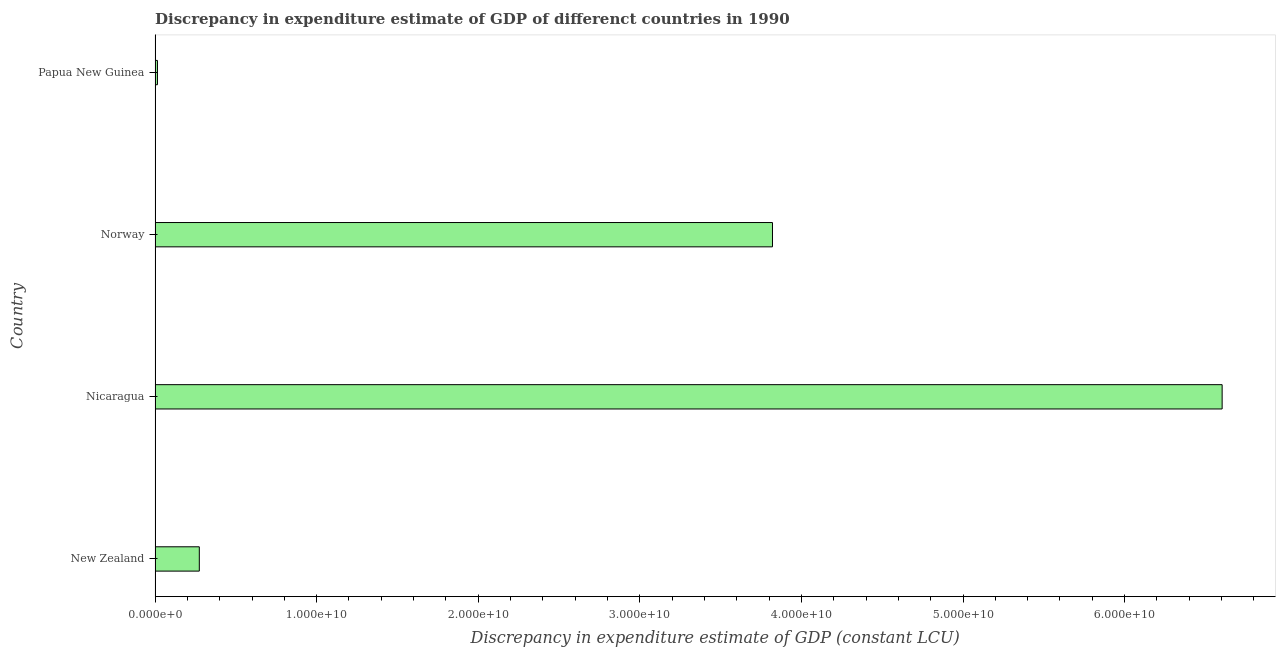Does the graph contain any zero values?
Make the answer very short. No. What is the title of the graph?
Offer a very short reply. Discrepancy in expenditure estimate of GDP of differenct countries in 1990. What is the label or title of the X-axis?
Provide a short and direct response. Discrepancy in expenditure estimate of GDP (constant LCU). What is the label or title of the Y-axis?
Ensure brevity in your answer.  Country. What is the discrepancy in expenditure estimate of gdp in Papua New Guinea?
Give a very brief answer. 1.49e+08. Across all countries, what is the maximum discrepancy in expenditure estimate of gdp?
Keep it short and to the point. 6.60e+1. Across all countries, what is the minimum discrepancy in expenditure estimate of gdp?
Provide a short and direct response. 1.49e+08. In which country was the discrepancy in expenditure estimate of gdp maximum?
Keep it short and to the point. Nicaragua. In which country was the discrepancy in expenditure estimate of gdp minimum?
Ensure brevity in your answer.  Papua New Guinea. What is the sum of the discrepancy in expenditure estimate of gdp?
Give a very brief answer. 1.07e+11. What is the difference between the discrepancy in expenditure estimate of gdp in Norway and Papua New Guinea?
Offer a very short reply. 3.81e+1. What is the average discrepancy in expenditure estimate of gdp per country?
Make the answer very short. 2.68e+1. What is the median discrepancy in expenditure estimate of gdp?
Keep it short and to the point. 2.05e+1. What is the ratio of the discrepancy in expenditure estimate of gdp in New Zealand to that in Norway?
Your answer should be compact. 0.07. What is the difference between the highest and the second highest discrepancy in expenditure estimate of gdp?
Offer a terse response. 2.78e+1. What is the difference between the highest and the lowest discrepancy in expenditure estimate of gdp?
Offer a very short reply. 6.59e+1. In how many countries, is the discrepancy in expenditure estimate of gdp greater than the average discrepancy in expenditure estimate of gdp taken over all countries?
Your answer should be very brief. 2. How many bars are there?
Your answer should be very brief. 4. How many countries are there in the graph?
Your answer should be very brief. 4. What is the Discrepancy in expenditure estimate of GDP (constant LCU) of New Zealand?
Your answer should be very brief. 2.74e+09. What is the Discrepancy in expenditure estimate of GDP (constant LCU) in Nicaragua?
Your answer should be compact. 6.60e+1. What is the Discrepancy in expenditure estimate of GDP (constant LCU) of Norway?
Offer a terse response. 3.82e+1. What is the Discrepancy in expenditure estimate of GDP (constant LCU) of Papua New Guinea?
Your answer should be compact. 1.49e+08. What is the difference between the Discrepancy in expenditure estimate of GDP (constant LCU) in New Zealand and Nicaragua?
Offer a very short reply. -6.33e+1. What is the difference between the Discrepancy in expenditure estimate of GDP (constant LCU) in New Zealand and Norway?
Your response must be concise. -3.55e+1. What is the difference between the Discrepancy in expenditure estimate of GDP (constant LCU) in New Zealand and Papua New Guinea?
Provide a short and direct response. 2.59e+09. What is the difference between the Discrepancy in expenditure estimate of GDP (constant LCU) in Nicaragua and Norway?
Give a very brief answer. 2.78e+1. What is the difference between the Discrepancy in expenditure estimate of GDP (constant LCU) in Nicaragua and Papua New Guinea?
Your answer should be very brief. 6.59e+1. What is the difference between the Discrepancy in expenditure estimate of GDP (constant LCU) in Norway and Papua New Guinea?
Make the answer very short. 3.81e+1. What is the ratio of the Discrepancy in expenditure estimate of GDP (constant LCU) in New Zealand to that in Nicaragua?
Provide a succinct answer. 0.04. What is the ratio of the Discrepancy in expenditure estimate of GDP (constant LCU) in New Zealand to that in Norway?
Provide a short and direct response. 0.07. What is the ratio of the Discrepancy in expenditure estimate of GDP (constant LCU) in New Zealand to that in Papua New Guinea?
Your answer should be very brief. 18.33. What is the ratio of the Discrepancy in expenditure estimate of GDP (constant LCU) in Nicaragua to that in Norway?
Provide a succinct answer. 1.73. What is the ratio of the Discrepancy in expenditure estimate of GDP (constant LCU) in Nicaragua to that in Papua New Guinea?
Your answer should be compact. 442.04. What is the ratio of the Discrepancy in expenditure estimate of GDP (constant LCU) in Norway to that in Papua New Guinea?
Make the answer very short. 255.77. 